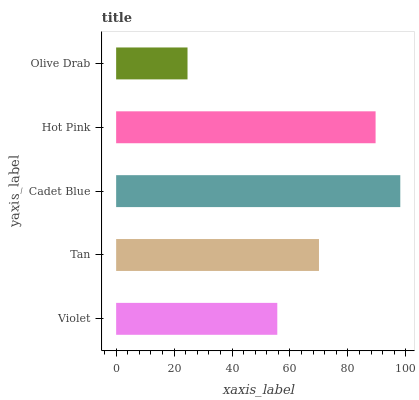Is Olive Drab the minimum?
Answer yes or no. Yes. Is Cadet Blue the maximum?
Answer yes or no. Yes. Is Tan the minimum?
Answer yes or no. No. Is Tan the maximum?
Answer yes or no. No. Is Tan greater than Violet?
Answer yes or no. Yes. Is Violet less than Tan?
Answer yes or no. Yes. Is Violet greater than Tan?
Answer yes or no. No. Is Tan less than Violet?
Answer yes or no. No. Is Tan the high median?
Answer yes or no. Yes. Is Tan the low median?
Answer yes or no. Yes. Is Hot Pink the high median?
Answer yes or no. No. Is Olive Drab the low median?
Answer yes or no. No. 